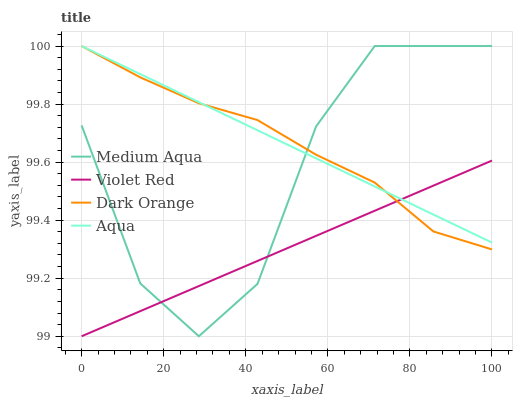Does Violet Red have the minimum area under the curve?
Answer yes or no. Yes. Does Aqua have the maximum area under the curve?
Answer yes or no. Yes. Does Dark Orange have the minimum area under the curve?
Answer yes or no. No. Does Dark Orange have the maximum area under the curve?
Answer yes or no. No. Is Violet Red the smoothest?
Answer yes or no. Yes. Is Medium Aqua the roughest?
Answer yes or no. Yes. Is Dark Orange the smoothest?
Answer yes or no. No. Is Dark Orange the roughest?
Answer yes or no. No. Does Violet Red have the lowest value?
Answer yes or no. Yes. Does Dark Orange have the lowest value?
Answer yes or no. No. Does Medium Aqua have the highest value?
Answer yes or no. Yes. Does Violet Red have the highest value?
Answer yes or no. No. Does Violet Red intersect Aqua?
Answer yes or no. Yes. Is Violet Red less than Aqua?
Answer yes or no. No. Is Violet Red greater than Aqua?
Answer yes or no. No. 